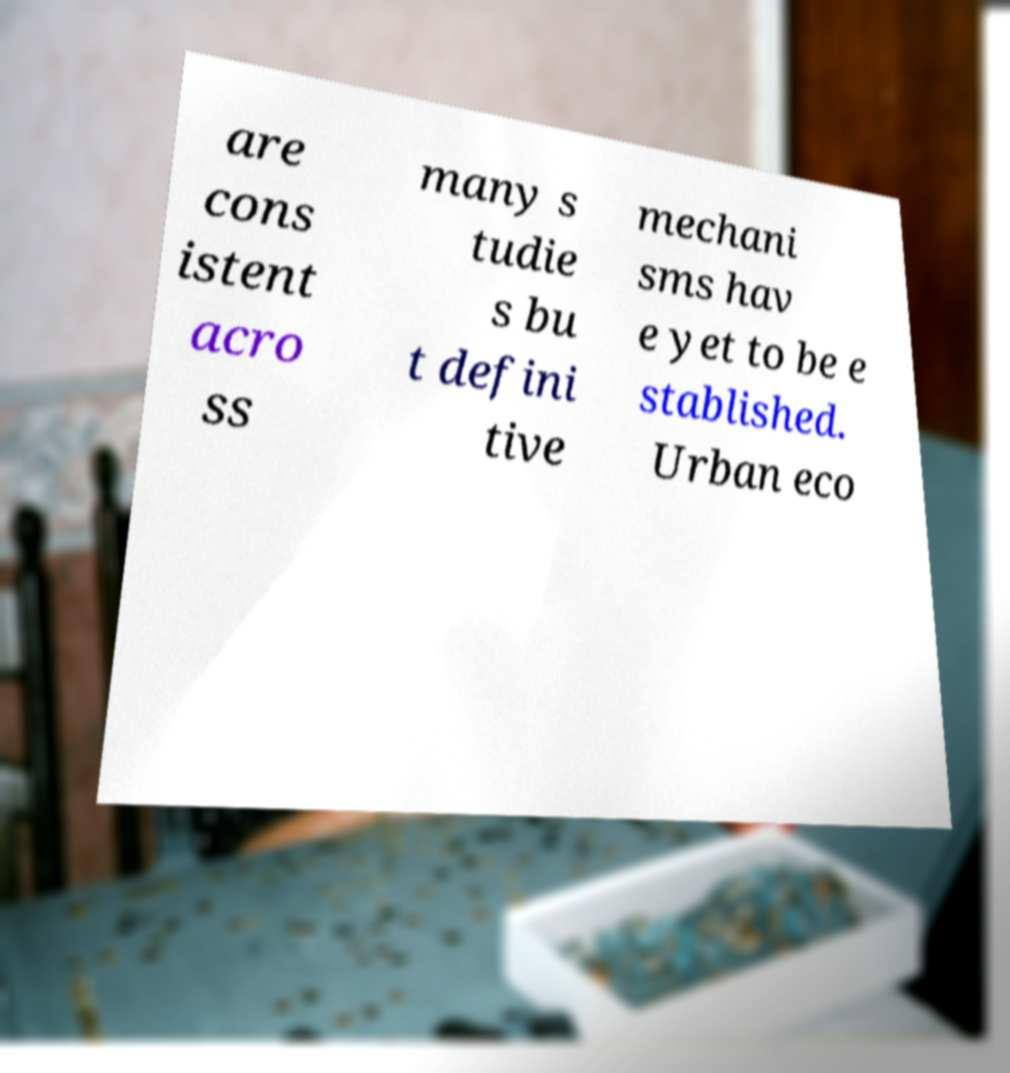Could you assist in decoding the text presented in this image and type it out clearly? are cons istent acro ss many s tudie s bu t defini tive mechani sms hav e yet to be e stablished. Urban eco 